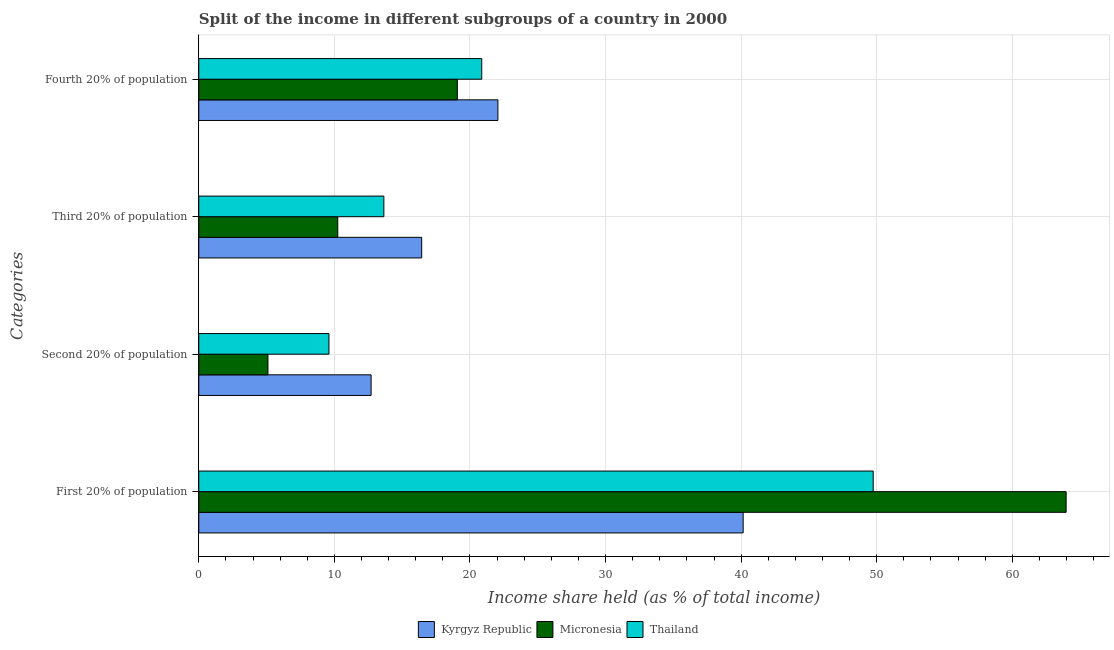How many different coloured bars are there?
Make the answer very short. 3. Are the number of bars on each tick of the Y-axis equal?
Your response must be concise. Yes. How many bars are there on the 4th tick from the top?
Your answer should be compact. 3. What is the label of the 2nd group of bars from the top?
Provide a short and direct response. Third 20% of population. What is the share of the income held by fourth 20% of the population in Kyrgyz Republic?
Your answer should be compact. 22.06. Across all countries, what is the maximum share of the income held by first 20% of the population?
Your answer should be very brief. 63.97. In which country was the share of the income held by first 20% of the population maximum?
Your answer should be very brief. Micronesia. In which country was the share of the income held by fourth 20% of the population minimum?
Keep it short and to the point. Micronesia. What is the total share of the income held by first 20% of the population in the graph?
Keep it short and to the point. 153.86. What is the difference between the share of the income held by second 20% of the population in Kyrgyz Republic and that in Micronesia?
Keep it short and to the point. 7.61. What is the difference between the share of the income held by first 20% of the population in Kyrgyz Republic and the share of the income held by second 20% of the population in Micronesia?
Ensure brevity in your answer.  35.05. What is the average share of the income held by second 20% of the population per country?
Ensure brevity in your answer.  9.14. What is the difference between the share of the income held by second 20% of the population and share of the income held by fourth 20% of the population in Micronesia?
Offer a terse response. -13.97. What is the ratio of the share of the income held by third 20% of the population in Kyrgyz Republic to that in Micronesia?
Give a very brief answer. 1.6. Is the difference between the share of the income held by first 20% of the population in Kyrgyz Republic and Micronesia greater than the difference between the share of the income held by fourth 20% of the population in Kyrgyz Republic and Micronesia?
Provide a succinct answer. No. What is the difference between the highest and the second highest share of the income held by fourth 20% of the population?
Your answer should be very brief. 1.19. What is the difference between the highest and the lowest share of the income held by second 20% of the population?
Offer a terse response. 7.61. In how many countries, is the share of the income held by third 20% of the population greater than the average share of the income held by third 20% of the population taken over all countries?
Ensure brevity in your answer.  2. Is the sum of the share of the income held by third 20% of the population in Micronesia and Kyrgyz Republic greater than the maximum share of the income held by second 20% of the population across all countries?
Offer a very short reply. Yes. What does the 3rd bar from the top in Second 20% of population represents?
Your answer should be very brief. Kyrgyz Republic. What does the 3rd bar from the bottom in Fourth 20% of population represents?
Give a very brief answer. Thailand. Is it the case that in every country, the sum of the share of the income held by first 20% of the population and share of the income held by second 20% of the population is greater than the share of the income held by third 20% of the population?
Your response must be concise. Yes. How many countries are there in the graph?
Offer a very short reply. 3. Does the graph contain grids?
Offer a terse response. Yes. Where does the legend appear in the graph?
Offer a very short reply. Bottom center. What is the title of the graph?
Provide a succinct answer. Split of the income in different subgroups of a country in 2000. Does "Isle of Man" appear as one of the legend labels in the graph?
Keep it short and to the point. No. What is the label or title of the X-axis?
Your answer should be very brief. Income share held (as % of total income). What is the label or title of the Y-axis?
Your answer should be compact. Categories. What is the Income share held (as % of total income) in Kyrgyz Republic in First 20% of population?
Offer a terse response. 40.15. What is the Income share held (as % of total income) of Micronesia in First 20% of population?
Give a very brief answer. 63.97. What is the Income share held (as % of total income) in Thailand in First 20% of population?
Provide a succinct answer. 49.74. What is the Income share held (as % of total income) of Kyrgyz Republic in Second 20% of population?
Provide a succinct answer. 12.71. What is the Income share held (as % of total income) of Micronesia in Second 20% of population?
Keep it short and to the point. 5.1. What is the Income share held (as % of total income) in Thailand in Second 20% of population?
Offer a very short reply. 9.6. What is the Income share held (as % of total income) in Kyrgyz Republic in Third 20% of population?
Give a very brief answer. 16.44. What is the Income share held (as % of total income) in Micronesia in Third 20% of population?
Keep it short and to the point. 10.25. What is the Income share held (as % of total income) in Thailand in Third 20% of population?
Provide a succinct answer. 13.65. What is the Income share held (as % of total income) in Kyrgyz Republic in Fourth 20% of population?
Provide a succinct answer. 22.06. What is the Income share held (as % of total income) in Micronesia in Fourth 20% of population?
Provide a succinct answer. 19.07. What is the Income share held (as % of total income) of Thailand in Fourth 20% of population?
Your response must be concise. 20.87. Across all Categories, what is the maximum Income share held (as % of total income) of Kyrgyz Republic?
Offer a very short reply. 40.15. Across all Categories, what is the maximum Income share held (as % of total income) of Micronesia?
Your answer should be very brief. 63.97. Across all Categories, what is the maximum Income share held (as % of total income) of Thailand?
Ensure brevity in your answer.  49.74. Across all Categories, what is the minimum Income share held (as % of total income) of Kyrgyz Republic?
Give a very brief answer. 12.71. What is the total Income share held (as % of total income) in Kyrgyz Republic in the graph?
Offer a very short reply. 91.36. What is the total Income share held (as % of total income) in Micronesia in the graph?
Your answer should be compact. 98.39. What is the total Income share held (as % of total income) of Thailand in the graph?
Make the answer very short. 93.86. What is the difference between the Income share held (as % of total income) of Kyrgyz Republic in First 20% of population and that in Second 20% of population?
Give a very brief answer. 27.44. What is the difference between the Income share held (as % of total income) in Micronesia in First 20% of population and that in Second 20% of population?
Your answer should be compact. 58.87. What is the difference between the Income share held (as % of total income) in Thailand in First 20% of population and that in Second 20% of population?
Your answer should be very brief. 40.14. What is the difference between the Income share held (as % of total income) of Kyrgyz Republic in First 20% of population and that in Third 20% of population?
Ensure brevity in your answer.  23.71. What is the difference between the Income share held (as % of total income) in Micronesia in First 20% of population and that in Third 20% of population?
Provide a short and direct response. 53.72. What is the difference between the Income share held (as % of total income) of Thailand in First 20% of population and that in Third 20% of population?
Offer a very short reply. 36.09. What is the difference between the Income share held (as % of total income) of Kyrgyz Republic in First 20% of population and that in Fourth 20% of population?
Your answer should be compact. 18.09. What is the difference between the Income share held (as % of total income) of Micronesia in First 20% of population and that in Fourth 20% of population?
Give a very brief answer. 44.9. What is the difference between the Income share held (as % of total income) of Thailand in First 20% of population and that in Fourth 20% of population?
Your response must be concise. 28.87. What is the difference between the Income share held (as % of total income) of Kyrgyz Republic in Second 20% of population and that in Third 20% of population?
Offer a terse response. -3.73. What is the difference between the Income share held (as % of total income) in Micronesia in Second 20% of population and that in Third 20% of population?
Ensure brevity in your answer.  -5.15. What is the difference between the Income share held (as % of total income) in Thailand in Second 20% of population and that in Third 20% of population?
Ensure brevity in your answer.  -4.05. What is the difference between the Income share held (as % of total income) in Kyrgyz Republic in Second 20% of population and that in Fourth 20% of population?
Give a very brief answer. -9.35. What is the difference between the Income share held (as % of total income) of Micronesia in Second 20% of population and that in Fourth 20% of population?
Offer a very short reply. -13.97. What is the difference between the Income share held (as % of total income) in Thailand in Second 20% of population and that in Fourth 20% of population?
Your answer should be compact. -11.27. What is the difference between the Income share held (as % of total income) in Kyrgyz Republic in Third 20% of population and that in Fourth 20% of population?
Offer a very short reply. -5.62. What is the difference between the Income share held (as % of total income) of Micronesia in Third 20% of population and that in Fourth 20% of population?
Offer a terse response. -8.82. What is the difference between the Income share held (as % of total income) of Thailand in Third 20% of population and that in Fourth 20% of population?
Keep it short and to the point. -7.22. What is the difference between the Income share held (as % of total income) of Kyrgyz Republic in First 20% of population and the Income share held (as % of total income) of Micronesia in Second 20% of population?
Your response must be concise. 35.05. What is the difference between the Income share held (as % of total income) in Kyrgyz Republic in First 20% of population and the Income share held (as % of total income) in Thailand in Second 20% of population?
Make the answer very short. 30.55. What is the difference between the Income share held (as % of total income) in Micronesia in First 20% of population and the Income share held (as % of total income) in Thailand in Second 20% of population?
Your response must be concise. 54.37. What is the difference between the Income share held (as % of total income) of Kyrgyz Republic in First 20% of population and the Income share held (as % of total income) of Micronesia in Third 20% of population?
Give a very brief answer. 29.9. What is the difference between the Income share held (as % of total income) of Micronesia in First 20% of population and the Income share held (as % of total income) of Thailand in Third 20% of population?
Keep it short and to the point. 50.32. What is the difference between the Income share held (as % of total income) of Kyrgyz Republic in First 20% of population and the Income share held (as % of total income) of Micronesia in Fourth 20% of population?
Offer a very short reply. 21.08. What is the difference between the Income share held (as % of total income) in Kyrgyz Republic in First 20% of population and the Income share held (as % of total income) in Thailand in Fourth 20% of population?
Make the answer very short. 19.28. What is the difference between the Income share held (as % of total income) in Micronesia in First 20% of population and the Income share held (as % of total income) in Thailand in Fourth 20% of population?
Give a very brief answer. 43.1. What is the difference between the Income share held (as % of total income) in Kyrgyz Republic in Second 20% of population and the Income share held (as % of total income) in Micronesia in Third 20% of population?
Provide a short and direct response. 2.46. What is the difference between the Income share held (as % of total income) of Kyrgyz Republic in Second 20% of population and the Income share held (as % of total income) of Thailand in Third 20% of population?
Your answer should be very brief. -0.94. What is the difference between the Income share held (as % of total income) in Micronesia in Second 20% of population and the Income share held (as % of total income) in Thailand in Third 20% of population?
Provide a short and direct response. -8.55. What is the difference between the Income share held (as % of total income) of Kyrgyz Republic in Second 20% of population and the Income share held (as % of total income) of Micronesia in Fourth 20% of population?
Make the answer very short. -6.36. What is the difference between the Income share held (as % of total income) in Kyrgyz Republic in Second 20% of population and the Income share held (as % of total income) in Thailand in Fourth 20% of population?
Give a very brief answer. -8.16. What is the difference between the Income share held (as % of total income) in Micronesia in Second 20% of population and the Income share held (as % of total income) in Thailand in Fourth 20% of population?
Ensure brevity in your answer.  -15.77. What is the difference between the Income share held (as % of total income) of Kyrgyz Republic in Third 20% of population and the Income share held (as % of total income) of Micronesia in Fourth 20% of population?
Offer a terse response. -2.63. What is the difference between the Income share held (as % of total income) in Kyrgyz Republic in Third 20% of population and the Income share held (as % of total income) in Thailand in Fourth 20% of population?
Ensure brevity in your answer.  -4.43. What is the difference between the Income share held (as % of total income) of Micronesia in Third 20% of population and the Income share held (as % of total income) of Thailand in Fourth 20% of population?
Provide a short and direct response. -10.62. What is the average Income share held (as % of total income) in Kyrgyz Republic per Categories?
Keep it short and to the point. 22.84. What is the average Income share held (as % of total income) in Micronesia per Categories?
Offer a very short reply. 24.6. What is the average Income share held (as % of total income) of Thailand per Categories?
Your answer should be compact. 23.46. What is the difference between the Income share held (as % of total income) in Kyrgyz Republic and Income share held (as % of total income) in Micronesia in First 20% of population?
Make the answer very short. -23.82. What is the difference between the Income share held (as % of total income) of Kyrgyz Republic and Income share held (as % of total income) of Thailand in First 20% of population?
Offer a terse response. -9.59. What is the difference between the Income share held (as % of total income) of Micronesia and Income share held (as % of total income) of Thailand in First 20% of population?
Give a very brief answer. 14.23. What is the difference between the Income share held (as % of total income) in Kyrgyz Republic and Income share held (as % of total income) in Micronesia in Second 20% of population?
Your answer should be compact. 7.61. What is the difference between the Income share held (as % of total income) of Kyrgyz Republic and Income share held (as % of total income) of Thailand in Second 20% of population?
Offer a very short reply. 3.11. What is the difference between the Income share held (as % of total income) in Kyrgyz Republic and Income share held (as % of total income) in Micronesia in Third 20% of population?
Your response must be concise. 6.19. What is the difference between the Income share held (as % of total income) of Kyrgyz Republic and Income share held (as % of total income) of Thailand in Third 20% of population?
Your response must be concise. 2.79. What is the difference between the Income share held (as % of total income) of Kyrgyz Republic and Income share held (as % of total income) of Micronesia in Fourth 20% of population?
Provide a short and direct response. 2.99. What is the difference between the Income share held (as % of total income) of Kyrgyz Republic and Income share held (as % of total income) of Thailand in Fourth 20% of population?
Offer a terse response. 1.19. What is the difference between the Income share held (as % of total income) of Micronesia and Income share held (as % of total income) of Thailand in Fourth 20% of population?
Your answer should be very brief. -1.8. What is the ratio of the Income share held (as % of total income) in Kyrgyz Republic in First 20% of population to that in Second 20% of population?
Provide a short and direct response. 3.16. What is the ratio of the Income share held (as % of total income) of Micronesia in First 20% of population to that in Second 20% of population?
Provide a succinct answer. 12.54. What is the ratio of the Income share held (as % of total income) of Thailand in First 20% of population to that in Second 20% of population?
Keep it short and to the point. 5.18. What is the ratio of the Income share held (as % of total income) in Kyrgyz Republic in First 20% of population to that in Third 20% of population?
Make the answer very short. 2.44. What is the ratio of the Income share held (as % of total income) in Micronesia in First 20% of population to that in Third 20% of population?
Provide a short and direct response. 6.24. What is the ratio of the Income share held (as % of total income) of Thailand in First 20% of population to that in Third 20% of population?
Provide a succinct answer. 3.64. What is the ratio of the Income share held (as % of total income) of Kyrgyz Republic in First 20% of population to that in Fourth 20% of population?
Keep it short and to the point. 1.82. What is the ratio of the Income share held (as % of total income) in Micronesia in First 20% of population to that in Fourth 20% of population?
Your response must be concise. 3.35. What is the ratio of the Income share held (as % of total income) of Thailand in First 20% of population to that in Fourth 20% of population?
Provide a short and direct response. 2.38. What is the ratio of the Income share held (as % of total income) of Kyrgyz Republic in Second 20% of population to that in Third 20% of population?
Your answer should be very brief. 0.77. What is the ratio of the Income share held (as % of total income) in Micronesia in Second 20% of population to that in Third 20% of population?
Ensure brevity in your answer.  0.5. What is the ratio of the Income share held (as % of total income) in Thailand in Second 20% of population to that in Third 20% of population?
Your answer should be very brief. 0.7. What is the ratio of the Income share held (as % of total income) of Kyrgyz Republic in Second 20% of population to that in Fourth 20% of population?
Make the answer very short. 0.58. What is the ratio of the Income share held (as % of total income) of Micronesia in Second 20% of population to that in Fourth 20% of population?
Provide a succinct answer. 0.27. What is the ratio of the Income share held (as % of total income) of Thailand in Second 20% of population to that in Fourth 20% of population?
Your response must be concise. 0.46. What is the ratio of the Income share held (as % of total income) of Kyrgyz Republic in Third 20% of population to that in Fourth 20% of population?
Make the answer very short. 0.75. What is the ratio of the Income share held (as % of total income) in Micronesia in Third 20% of population to that in Fourth 20% of population?
Keep it short and to the point. 0.54. What is the ratio of the Income share held (as % of total income) in Thailand in Third 20% of population to that in Fourth 20% of population?
Provide a short and direct response. 0.65. What is the difference between the highest and the second highest Income share held (as % of total income) in Kyrgyz Republic?
Keep it short and to the point. 18.09. What is the difference between the highest and the second highest Income share held (as % of total income) in Micronesia?
Offer a terse response. 44.9. What is the difference between the highest and the second highest Income share held (as % of total income) of Thailand?
Ensure brevity in your answer.  28.87. What is the difference between the highest and the lowest Income share held (as % of total income) in Kyrgyz Republic?
Your answer should be compact. 27.44. What is the difference between the highest and the lowest Income share held (as % of total income) in Micronesia?
Your answer should be very brief. 58.87. What is the difference between the highest and the lowest Income share held (as % of total income) in Thailand?
Your response must be concise. 40.14. 